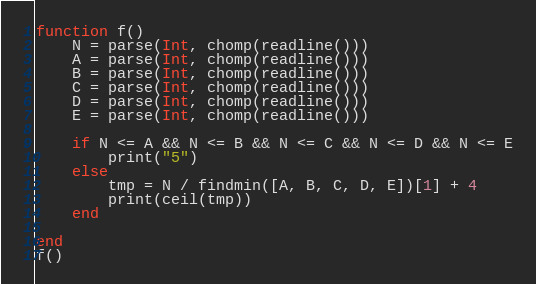<code> <loc_0><loc_0><loc_500><loc_500><_Julia_>function f()
    N = parse(Int, chomp(readline()))
    A = parse(Int, chomp(readline()))
    B = parse(Int, chomp(readline()))
    C = parse(Int, chomp(readline()))
    D = parse(Int, chomp(readline()))
    E = parse(Int, chomp(readline()))

    if N <= A && N <= B && N <= C && N <= D && N <= E
        print("5")
    else
        tmp = N / findmin([A, B, C, D, E])[1] + 4
        print(ceil(tmp))
    end

end
f()</code> 